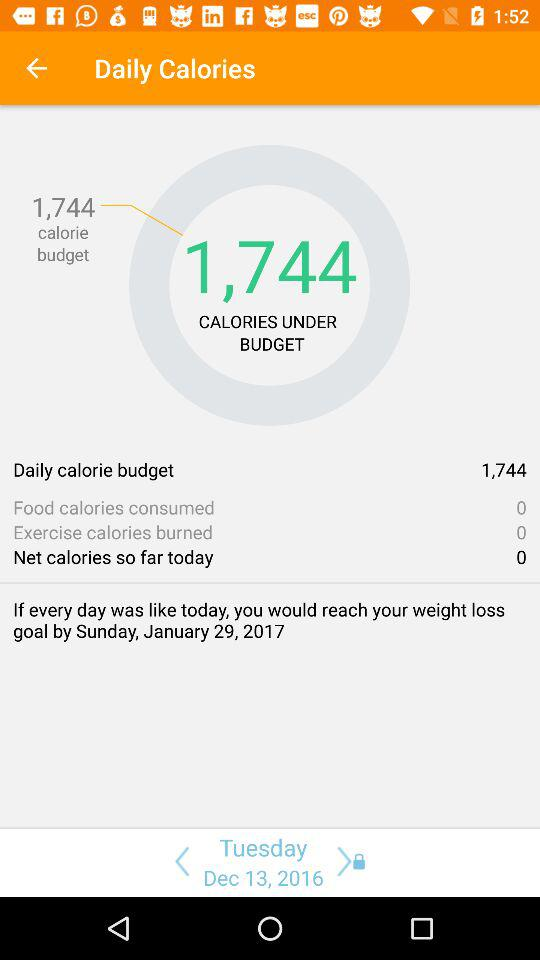What is the daily calorie budget? The daily calorie budget is 1,744. 